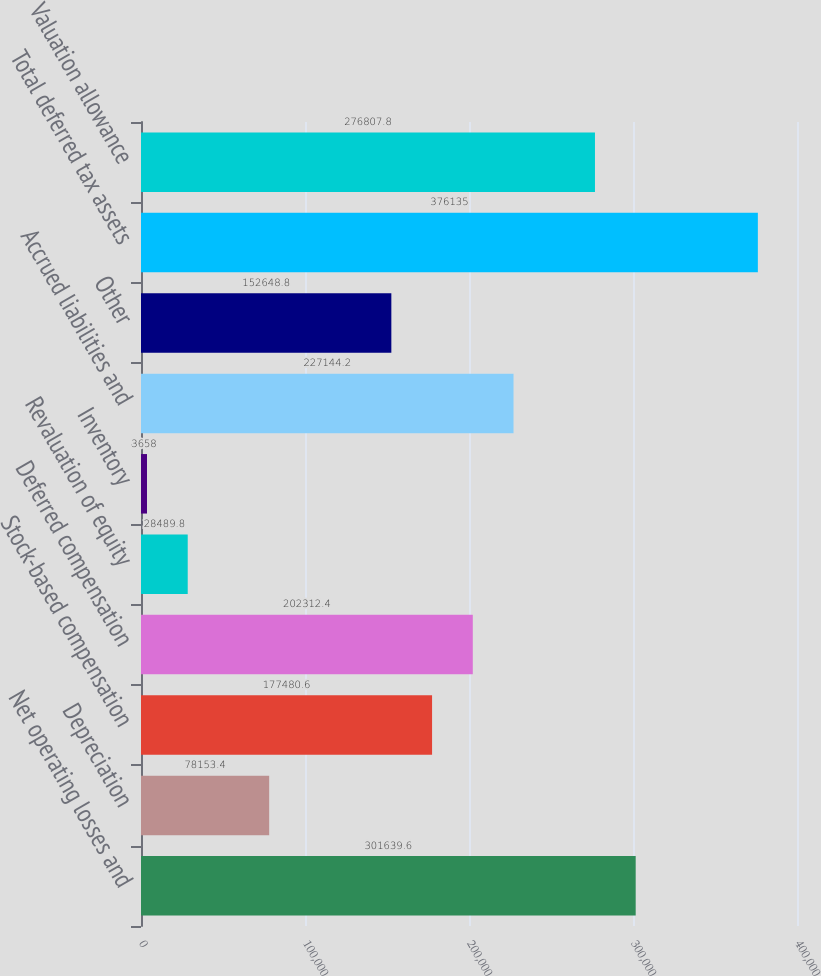Convert chart to OTSL. <chart><loc_0><loc_0><loc_500><loc_500><bar_chart><fcel>Net operating losses and<fcel>Depreciation<fcel>Stock-based compensation<fcel>Deferred compensation<fcel>Revaluation of equity<fcel>Inventory<fcel>Accrued liabilities and<fcel>Other<fcel>Total deferred tax assets<fcel>Valuation allowance<nl><fcel>301640<fcel>78153.4<fcel>177481<fcel>202312<fcel>28489.8<fcel>3658<fcel>227144<fcel>152649<fcel>376135<fcel>276808<nl></chart> 